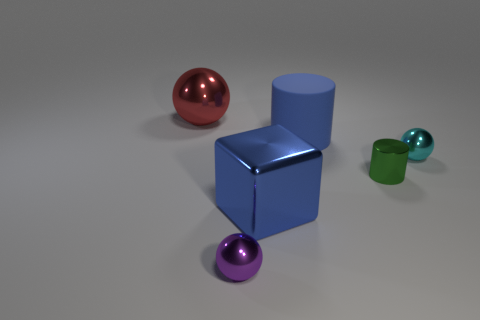Subtract all tiny balls. How many balls are left? 1 Add 3 small metallic balls. How many objects exist? 9 Subtract 1 balls. How many balls are left? 2 Subtract all cubes. How many objects are left? 5 Subtract all yellow spheres. Subtract all green blocks. How many spheres are left? 3 Add 2 metal balls. How many metal balls exist? 5 Subtract 1 red spheres. How many objects are left? 5 Subtract all purple cylinders. Subtract all large blue blocks. How many objects are left? 5 Add 4 small purple things. How many small purple things are left? 5 